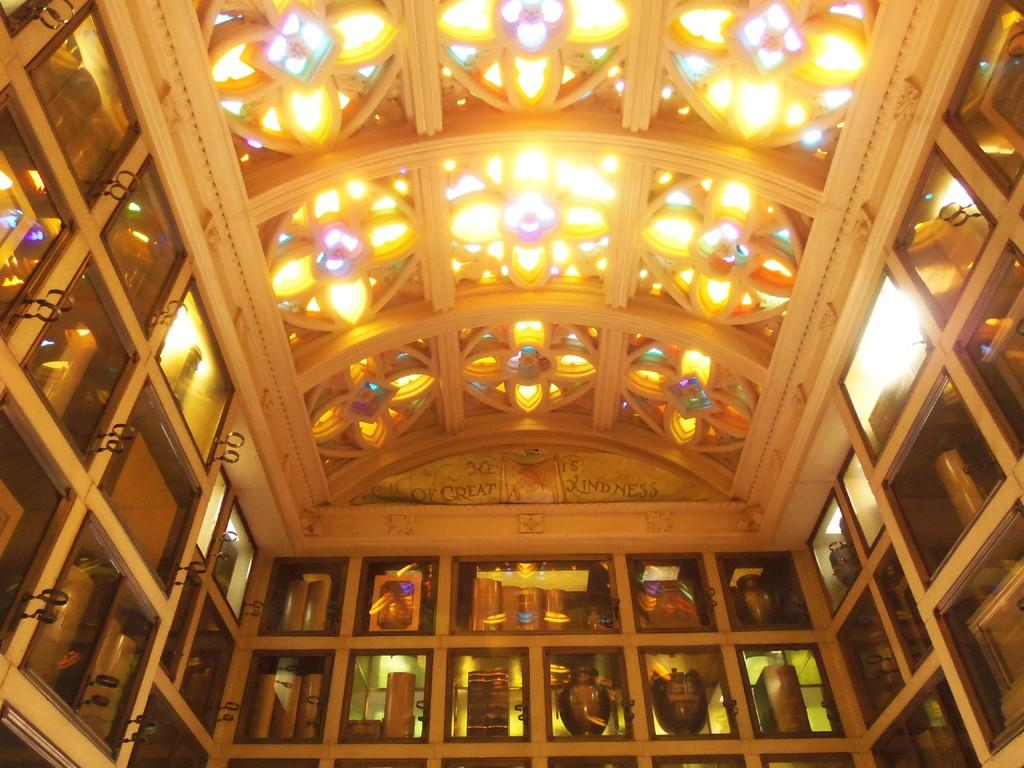What type of objects can be seen in the image? There are pots in the image. Where are some of the objects stored in the image? There are objects in cupboards in the image. What can be seen on the ceiling in the image? There are lights on the ceiling in the image. What type of quartz is present in the image? There is no quartz present in the image. How low is the downtown area in the image? The image does not depict a downtown area, so it cannot be determined how low it is. 